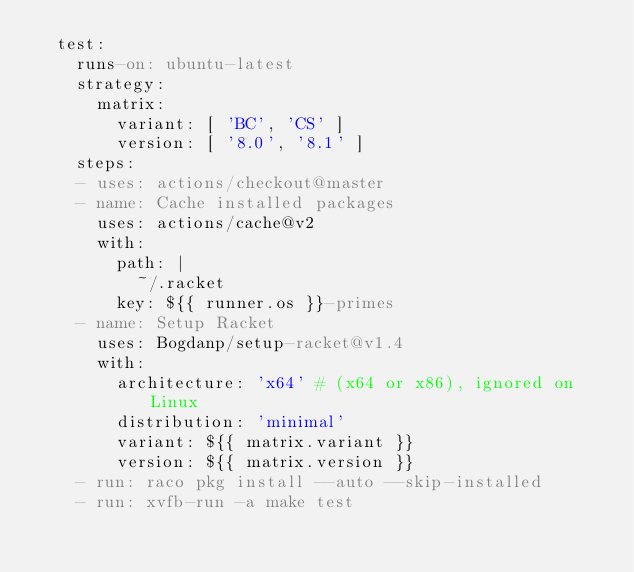Convert code to text. <code><loc_0><loc_0><loc_500><loc_500><_YAML_>  test:
    runs-on: ubuntu-latest
    strategy:
      matrix:
        variant: [ 'BC', 'CS' ]
        version: [ '8.0', '8.1' ]
    steps:
    - uses: actions/checkout@master
    - name: Cache installed packages
      uses: actions/cache@v2
      with:
        path: |
          ~/.racket
        key: ${{ runner.os }}-primes
    - name: Setup Racket
      uses: Bogdanp/setup-racket@v1.4
      with:
        architecture: 'x64' # (x64 or x86), ignored on Linux
        distribution: 'minimal'
        variant: ${{ matrix.variant }}
        version: ${{ matrix.version }}
    - run: raco pkg install --auto --skip-installed
    - run: xvfb-run -a make test
</code> 